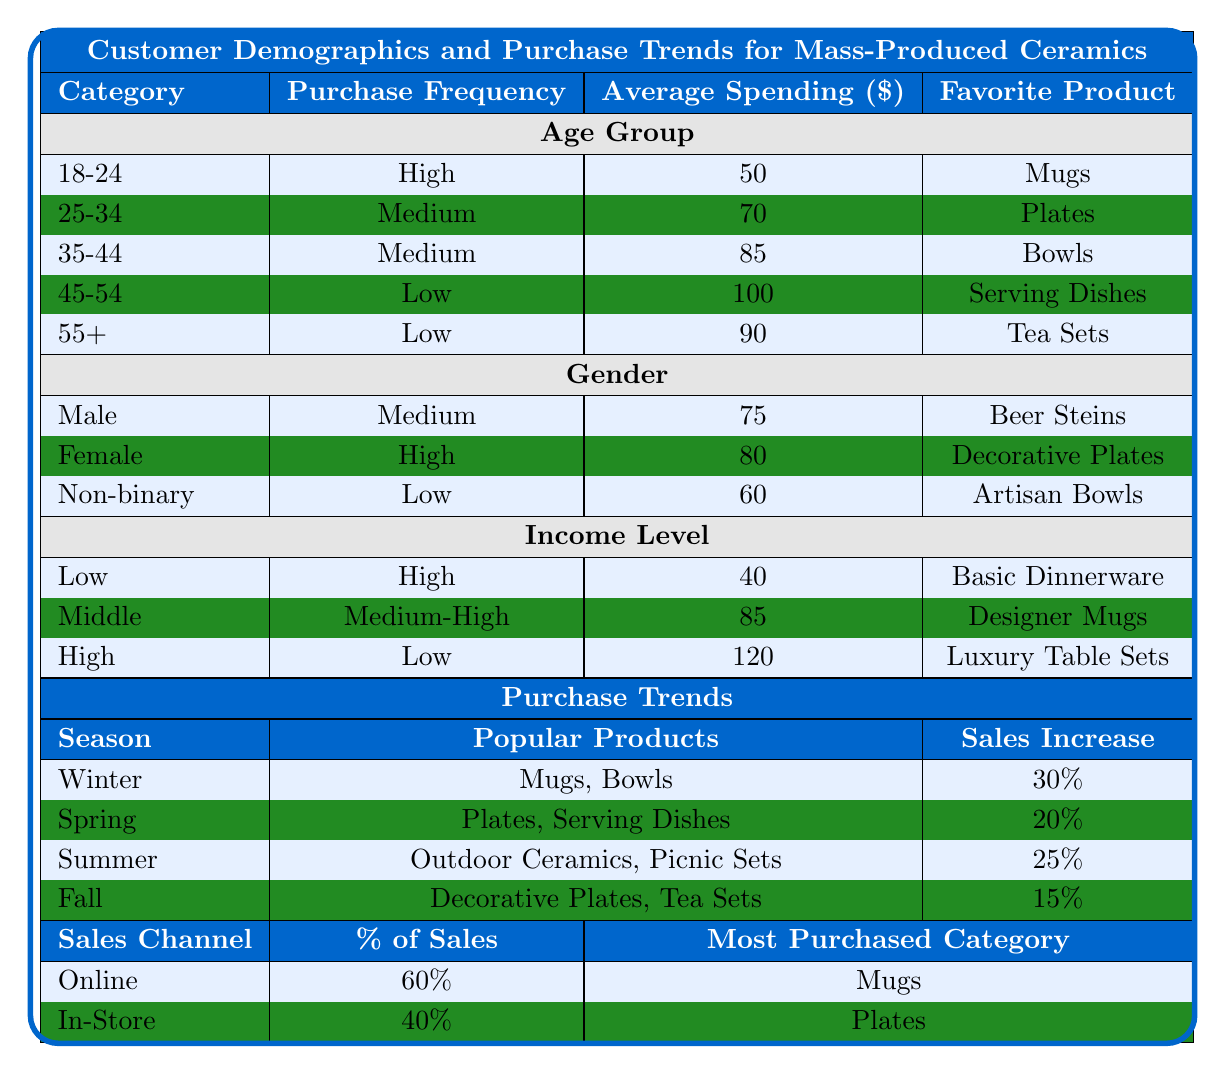What is the favorite product for the age group 25-34? According to the table, the favorite product for the 25-34 age group is "Plates."
Answer: Plates What is the average spending for the income level classified as 'Low'? The table indicates that the average spending for the 'Low' income level is $40.
Answer: 40 Do females have a higher purchase frequency than males? Yes, the table shows that females have a "High" purchase frequency while males have a "Medium" purchase frequency.
Answer: Yes Which season shows the highest sales increase? From the seasonal trends, Winter has the highest sales increase at 30%.
Answer: Winter What percentage of sales come from online channels? The table states that 60% of sales are from online channels.
Answer: 60% Is there a favorite product for the 55+ age group? Yes, the favorite product for the 55+ age group is "Tea Sets."
Answer: Yes Calculate the average spending across all age groups. The average spending across all age groups is calculated by summing the average spendings ($50 + $70 + $85 + $100 + $90 = $395) and dividing by the number of age groups (5): $395 / 5 = $79.
Answer: 79 Do 'Middle' income individuals have a higher average spending than 'Low' income individuals? Yes, the average spending for middle income is $85, which is higher than $40 for low income.
Answer: Yes What is the most purchased category for in-store purchases? The table specifies that the most purchased category for in-store purchases is "Plates."
Answer: Plates Which age group has the lowest average spending? The lowest average spending is with the 'Low' income group, which is $40.
Answer: 40 